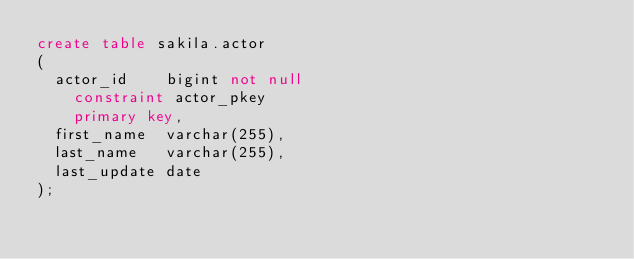Convert code to text. <code><loc_0><loc_0><loc_500><loc_500><_SQL_>create table sakila.actor
(
  actor_id    bigint not null
    constraint actor_pkey
    primary key,
  first_name  varchar(255),
  last_name   varchar(255),
  last_update date
);
</code> 